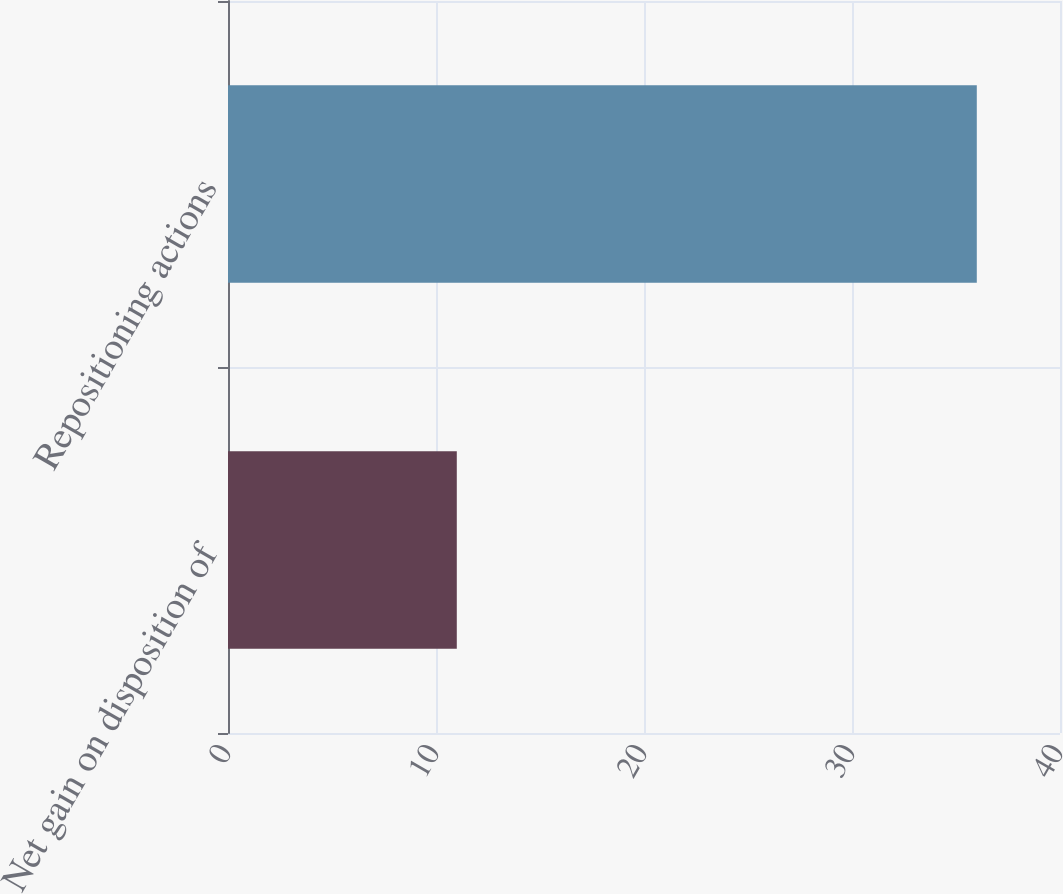Convert chart. <chart><loc_0><loc_0><loc_500><loc_500><bar_chart><fcel>Net gain on disposition of<fcel>Repositioning actions<nl><fcel>11<fcel>36<nl></chart> 